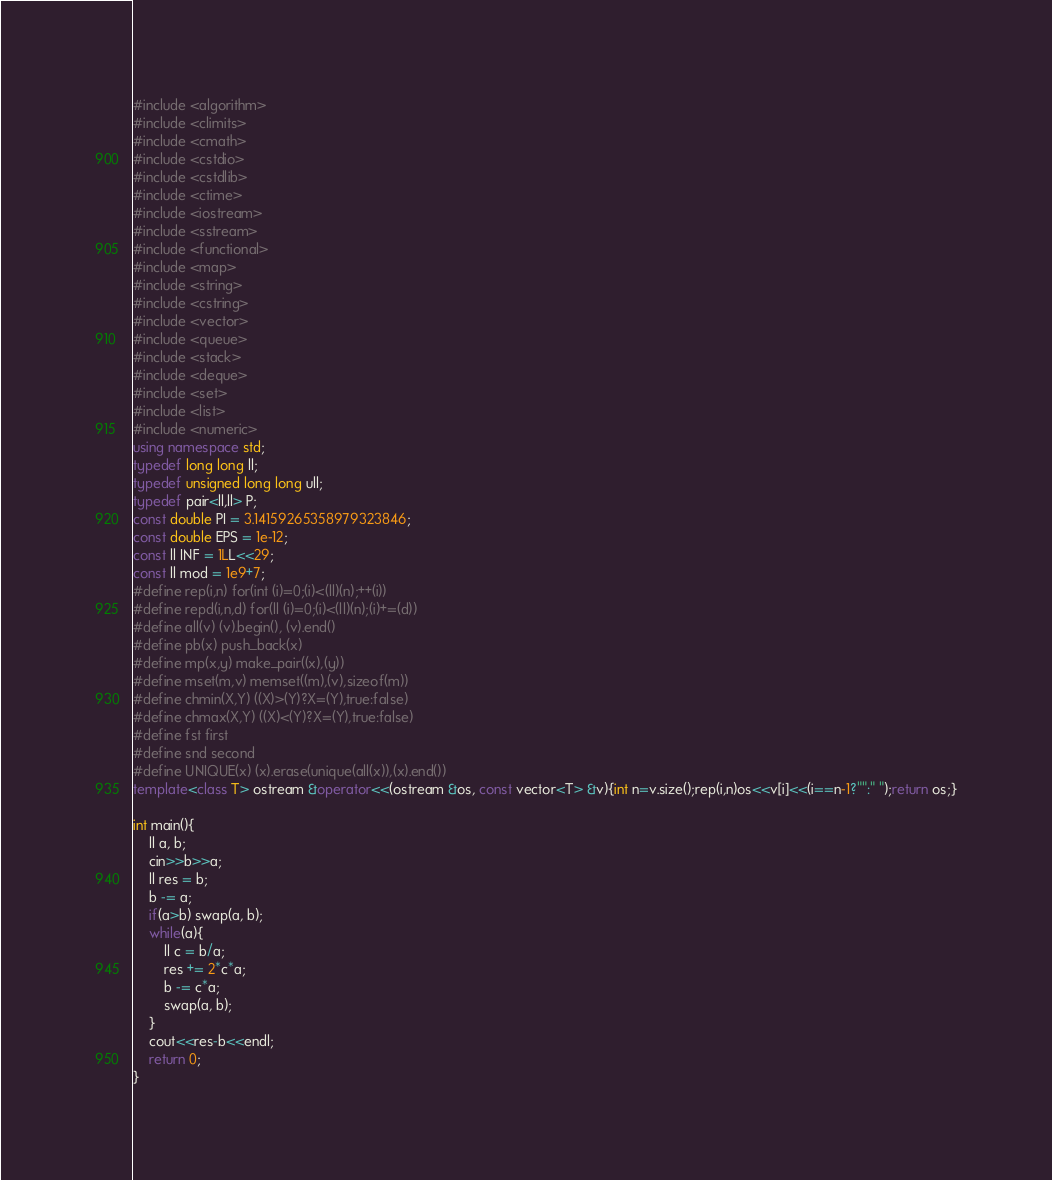Convert code to text. <code><loc_0><loc_0><loc_500><loc_500><_C++_>#include <algorithm>
#include <climits>
#include <cmath>
#include <cstdio>
#include <cstdlib>
#include <ctime>
#include <iostream>
#include <sstream>
#include <functional>
#include <map>
#include <string>
#include <cstring>
#include <vector>
#include <queue>
#include <stack>
#include <deque>
#include <set>
#include <list>
#include <numeric>
using namespace std;
typedef long long ll;
typedef unsigned long long ull;
typedef pair<ll,ll> P;
const double PI = 3.14159265358979323846;
const double EPS = 1e-12;
const ll INF = 1LL<<29;
const ll mod = 1e9+7;
#define rep(i,n) for(int (i)=0;(i)<(ll)(n);++(i))
#define repd(i,n,d) for(ll (i)=0;(i)<(ll)(n);(i)+=(d))
#define all(v) (v).begin(), (v).end()
#define pb(x) push_back(x)
#define mp(x,y) make_pair((x),(y))
#define mset(m,v) memset((m),(v),sizeof(m))
#define chmin(X,Y) ((X)>(Y)?X=(Y),true:false)
#define chmax(X,Y) ((X)<(Y)?X=(Y),true:false)
#define fst first
#define snd second
#define UNIQUE(x) (x).erase(unique(all(x)),(x).end())
template<class T> ostream &operator<<(ostream &os, const vector<T> &v){int n=v.size();rep(i,n)os<<v[i]<<(i==n-1?"":" ");return os;}

int main(){
	ll a, b;
	cin>>b>>a;
	ll res = b;
	b -= a;
	if(a>b) swap(a, b);
	while(a){
		ll c = b/a;
		res += 2*c*a;
		b -= c*a;
		swap(a, b);
	}
	cout<<res-b<<endl;
	return 0;
}
</code> 